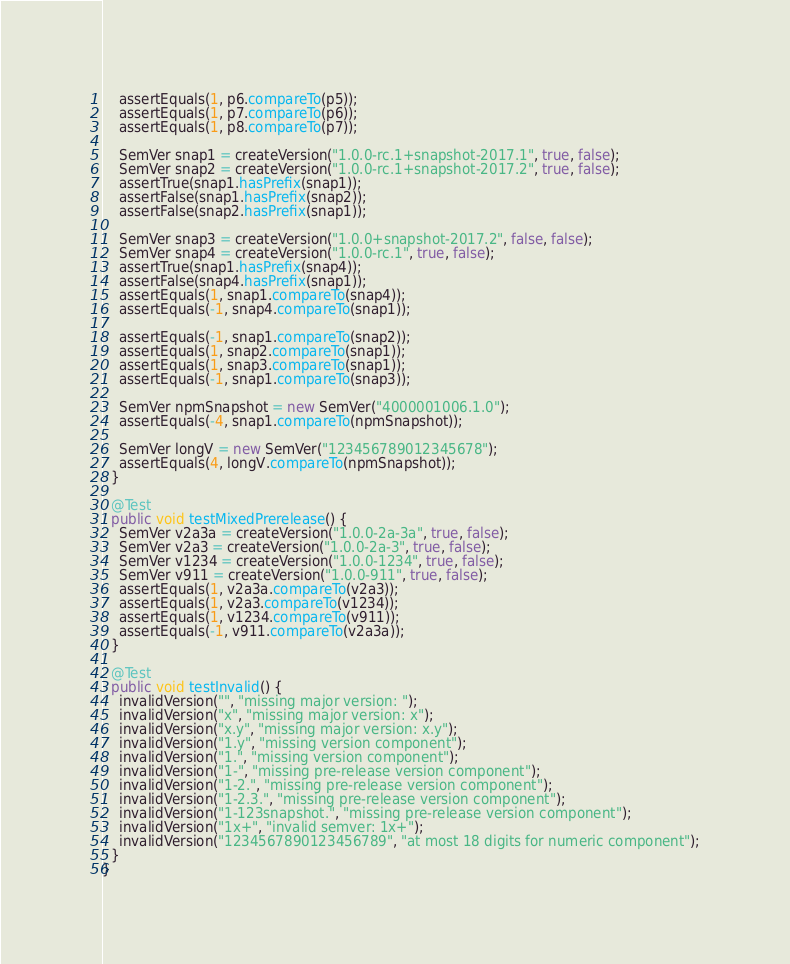Convert code to text. <code><loc_0><loc_0><loc_500><loc_500><_Java_>    assertEquals(1, p6.compareTo(p5));
    assertEquals(1, p7.compareTo(p6));
    assertEquals(1, p8.compareTo(p7));

    SemVer snap1 = createVersion("1.0.0-rc.1+snapshot-2017.1", true, false);
    SemVer snap2 = createVersion("1.0.0-rc.1+snapshot-2017.2", true, false);
    assertTrue(snap1.hasPrefix(snap1));
    assertFalse(snap1.hasPrefix(snap2));
    assertFalse(snap2.hasPrefix(snap1));

    SemVer snap3 = createVersion("1.0.0+snapshot-2017.2", false, false);
    SemVer snap4 = createVersion("1.0.0-rc.1", true, false);
    assertTrue(snap1.hasPrefix(snap4));
    assertFalse(snap4.hasPrefix(snap1));
    assertEquals(1, snap1.compareTo(snap4));
    assertEquals(-1, snap4.compareTo(snap1));

    assertEquals(-1, snap1.compareTo(snap2));
    assertEquals(1, snap2.compareTo(snap1));
    assertEquals(1, snap3.compareTo(snap1));
    assertEquals(-1, snap1.compareTo(snap3));

    SemVer npmSnapshot = new SemVer("4000001006.1.0");
    assertEquals(-4, snap1.compareTo(npmSnapshot));

    SemVer longV = new SemVer("123456789012345678");
    assertEquals(4, longV.compareTo(npmSnapshot));
  }

  @Test
  public void testMixedPrerelease() {
    SemVer v2a3a = createVersion("1.0.0-2a-3a", true, false);
    SemVer v2a3 = createVersion("1.0.0-2a-3", true, false);
    SemVer v1234 = createVersion("1.0.0-1234", true, false);
    SemVer v911 = createVersion("1.0.0-911", true, false);
    assertEquals(1, v2a3a.compareTo(v2a3));
    assertEquals(1, v2a3.compareTo(v1234));
    assertEquals(1, v1234.compareTo(v911));
    assertEquals(-1, v911.compareTo(v2a3a));
  }

  @Test
  public void testInvalid() {
    invalidVersion("", "missing major version: ");
    invalidVersion("x", "missing major version: x");
    invalidVersion("x.y", "missing major version: x.y");
    invalidVersion("1.y", "missing version component");
    invalidVersion("1.", "missing version component");
    invalidVersion("1-", "missing pre-release version component");
    invalidVersion("1-2.", "missing pre-release version component");
    invalidVersion("1-2.3.", "missing pre-release version component");
    invalidVersion("1-123snapshot.", "missing pre-release version component");
    invalidVersion("1x+", "invalid semver: 1x+");
    invalidVersion("1234567890123456789", "at most 18 digits for numeric component");
  }
}
</code> 